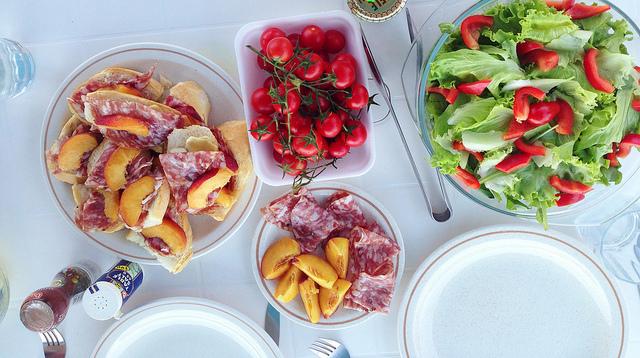Are there forks or spoons?
Concise answer only. Forks. What color is the dining ware?
Keep it brief. White. Can you eat these items?
Give a very brief answer. Yes. 